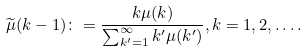<formula> <loc_0><loc_0><loc_500><loc_500>\widetilde { \mu } ( k - 1 ) \colon = \frac { k \mu ( k ) } { \sum _ { k ^ { \prime } = 1 } ^ { \infty } k ^ { \prime } \mu ( k ^ { \prime } ) } , k = 1 , 2 , \dots .</formula> 